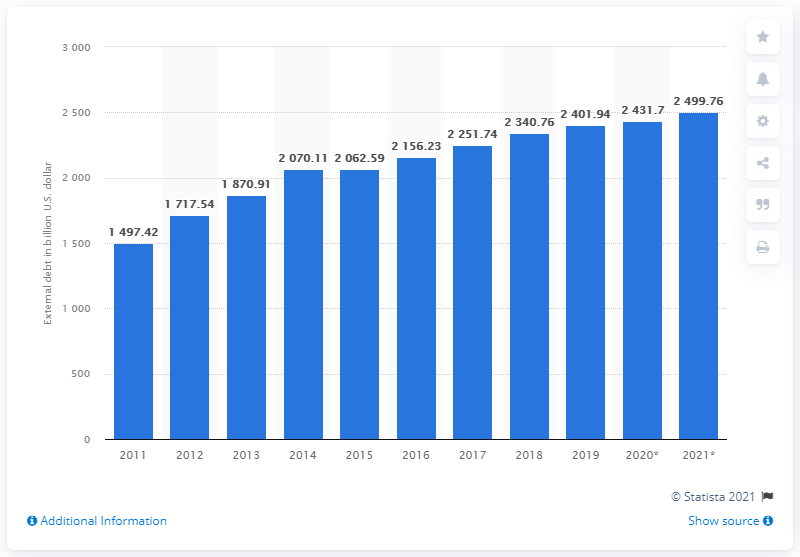Draw attention to some important aspects in this diagram. In 2019, the total amount of Latin America and the Caribbean's debt was 2401.94. 